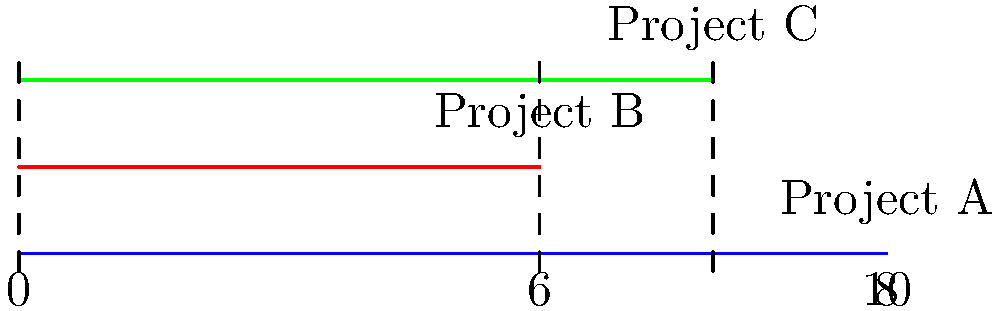In the diagram above, three GIS implementation projects are represented by parallel lines. Project A spans the entire timeline, Project B starts at the beginning and ends at week 6, and Project C starts at week 6 and ends at week 8. What is the total number of weeks where at least two projects are running concurrently? To solve this problem, we need to analyze the overlapping periods of the projects:

1. Project A runs for the entire 10-week period.
2. Project B runs from week 0 to week 6.
3. Project C runs from week 6 to week 8.

Let's break down the overlaps:

1. From week 0 to week 6:
   - Projects A and B are running concurrently.
   - This period lasts for 6 weeks.

2. From week 6 to week 8:
   - Projects A and C are running concurrently.
   - This period lasts for 2 weeks.

3. At week 6:
   - All three projects (A, B, and C) overlap.
   - However, this is already counted in both periods above.

To find the total number of weeks where at least two projects are running concurrently, we sum up the overlapping periods:

$6 \text{ weeks } + 2 \text{ weeks } = 8 \text{ weeks}$

Therefore, there are 8 weeks where at least two projects are running concurrently.
Answer: 8 weeks 